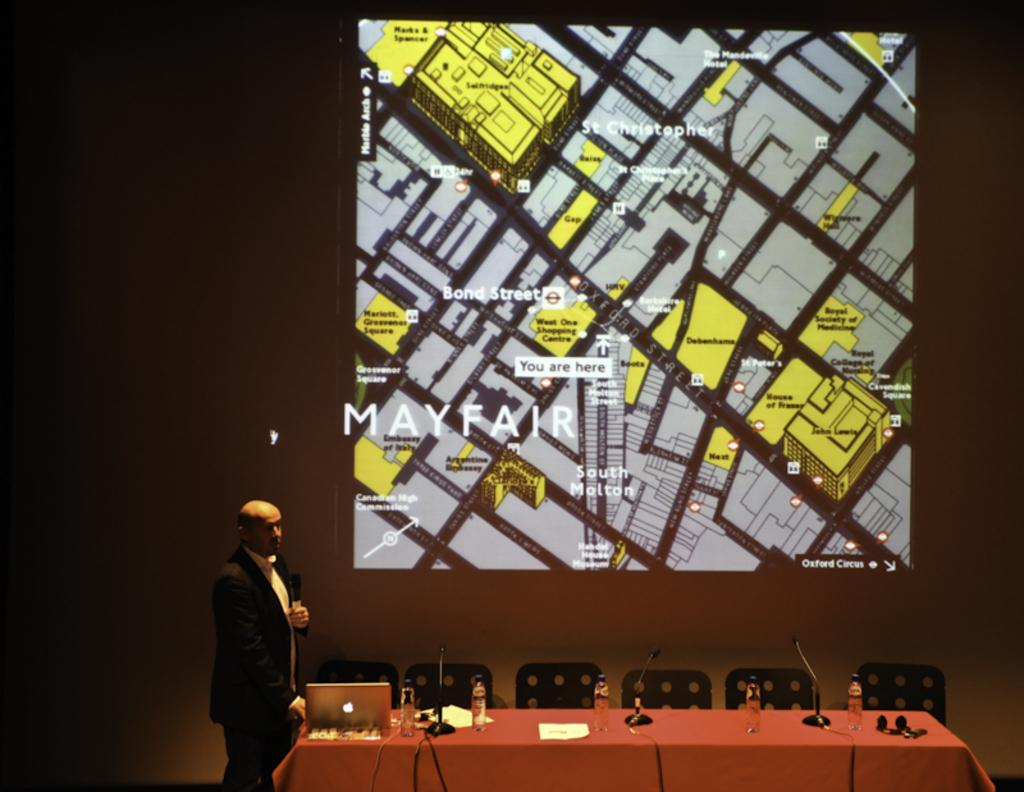What is the man in the image holding? The man is holding a microphone. What objects are on the table in the image? There is a laptop, a water bottle, and a paper on the table. What piece of furniture is in the image? There is a chair in the image. What type of wave can be seen crashing on the shore in the image? There is no wave or shore present in the image; it features a man holding a microphone, a table with various objects, and a chair. 